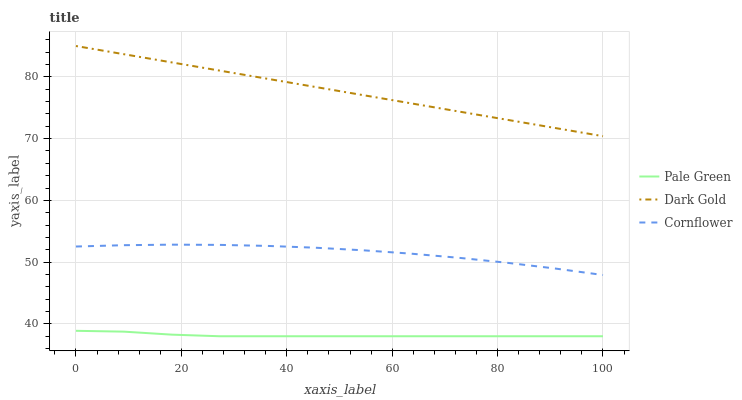Does Pale Green have the minimum area under the curve?
Answer yes or no. Yes. Does Dark Gold have the maximum area under the curve?
Answer yes or no. Yes. Does Dark Gold have the minimum area under the curve?
Answer yes or no. No. Does Pale Green have the maximum area under the curve?
Answer yes or no. No. Is Dark Gold the smoothest?
Answer yes or no. Yes. Is Cornflower the roughest?
Answer yes or no. Yes. Is Pale Green the smoothest?
Answer yes or no. No. Is Pale Green the roughest?
Answer yes or no. No. Does Pale Green have the lowest value?
Answer yes or no. Yes. Does Dark Gold have the lowest value?
Answer yes or no. No. Does Dark Gold have the highest value?
Answer yes or no. Yes. Does Pale Green have the highest value?
Answer yes or no. No. Is Pale Green less than Dark Gold?
Answer yes or no. Yes. Is Dark Gold greater than Pale Green?
Answer yes or no. Yes. Does Pale Green intersect Dark Gold?
Answer yes or no. No. 